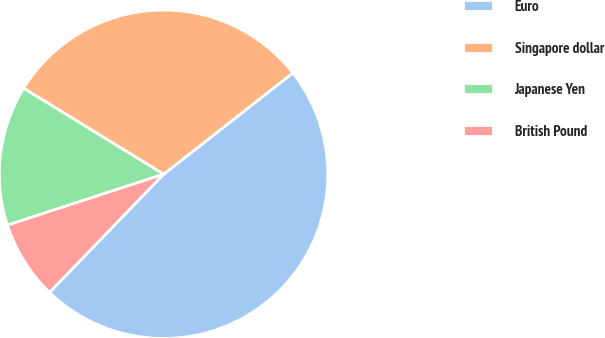Convert chart. <chart><loc_0><loc_0><loc_500><loc_500><pie_chart><fcel>Euro<fcel>Singapore dollar<fcel>Japanese Yen<fcel>British Pound<nl><fcel>47.81%<fcel>30.66%<fcel>13.78%<fcel>7.76%<nl></chart> 